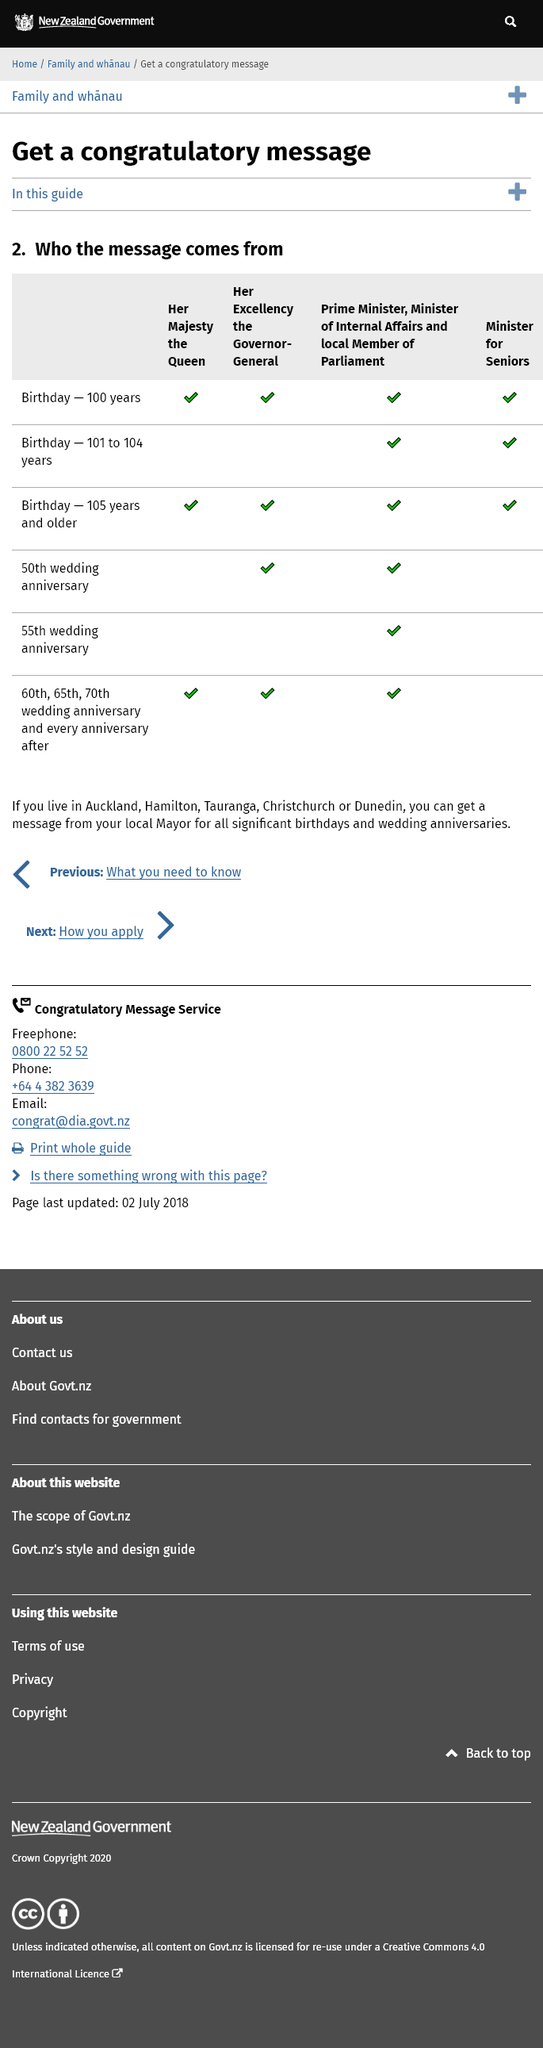Outline some significant characteristics in this image. In the towns of Auckland, Hamilton, Tauranga, Christchurch, and Dunedin, it is possible to receive a message from the local Mayor on significant birthdays. A congratulatory message can be sent to a person celebrating their 50th wedding anniversary by Her Excellency the Governor-General, the Prime Minister, the Minister for Internal Affairs, or a local Member of Parliament. It is 60 years after the date of a person's marriage before they receive a message from Her Majesty the Queen. 